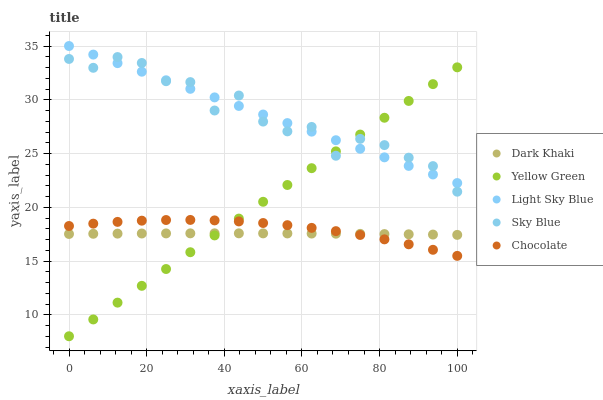Does Dark Khaki have the minimum area under the curve?
Answer yes or no. Yes. Does Sky Blue have the maximum area under the curve?
Answer yes or no. Yes. Does Light Sky Blue have the minimum area under the curve?
Answer yes or no. No. Does Light Sky Blue have the maximum area under the curve?
Answer yes or no. No. Is Yellow Green the smoothest?
Answer yes or no. Yes. Is Sky Blue the roughest?
Answer yes or no. Yes. Is Light Sky Blue the smoothest?
Answer yes or no. No. Is Light Sky Blue the roughest?
Answer yes or no. No. Does Yellow Green have the lowest value?
Answer yes or no. Yes. Does Sky Blue have the lowest value?
Answer yes or no. No. Does Light Sky Blue have the highest value?
Answer yes or no. Yes. Does Sky Blue have the highest value?
Answer yes or no. No. Is Dark Khaki less than Sky Blue?
Answer yes or no. Yes. Is Light Sky Blue greater than Chocolate?
Answer yes or no. Yes. Does Light Sky Blue intersect Yellow Green?
Answer yes or no. Yes. Is Light Sky Blue less than Yellow Green?
Answer yes or no. No. Is Light Sky Blue greater than Yellow Green?
Answer yes or no. No. Does Dark Khaki intersect Sky Blue?
Answer yes or no. No. 